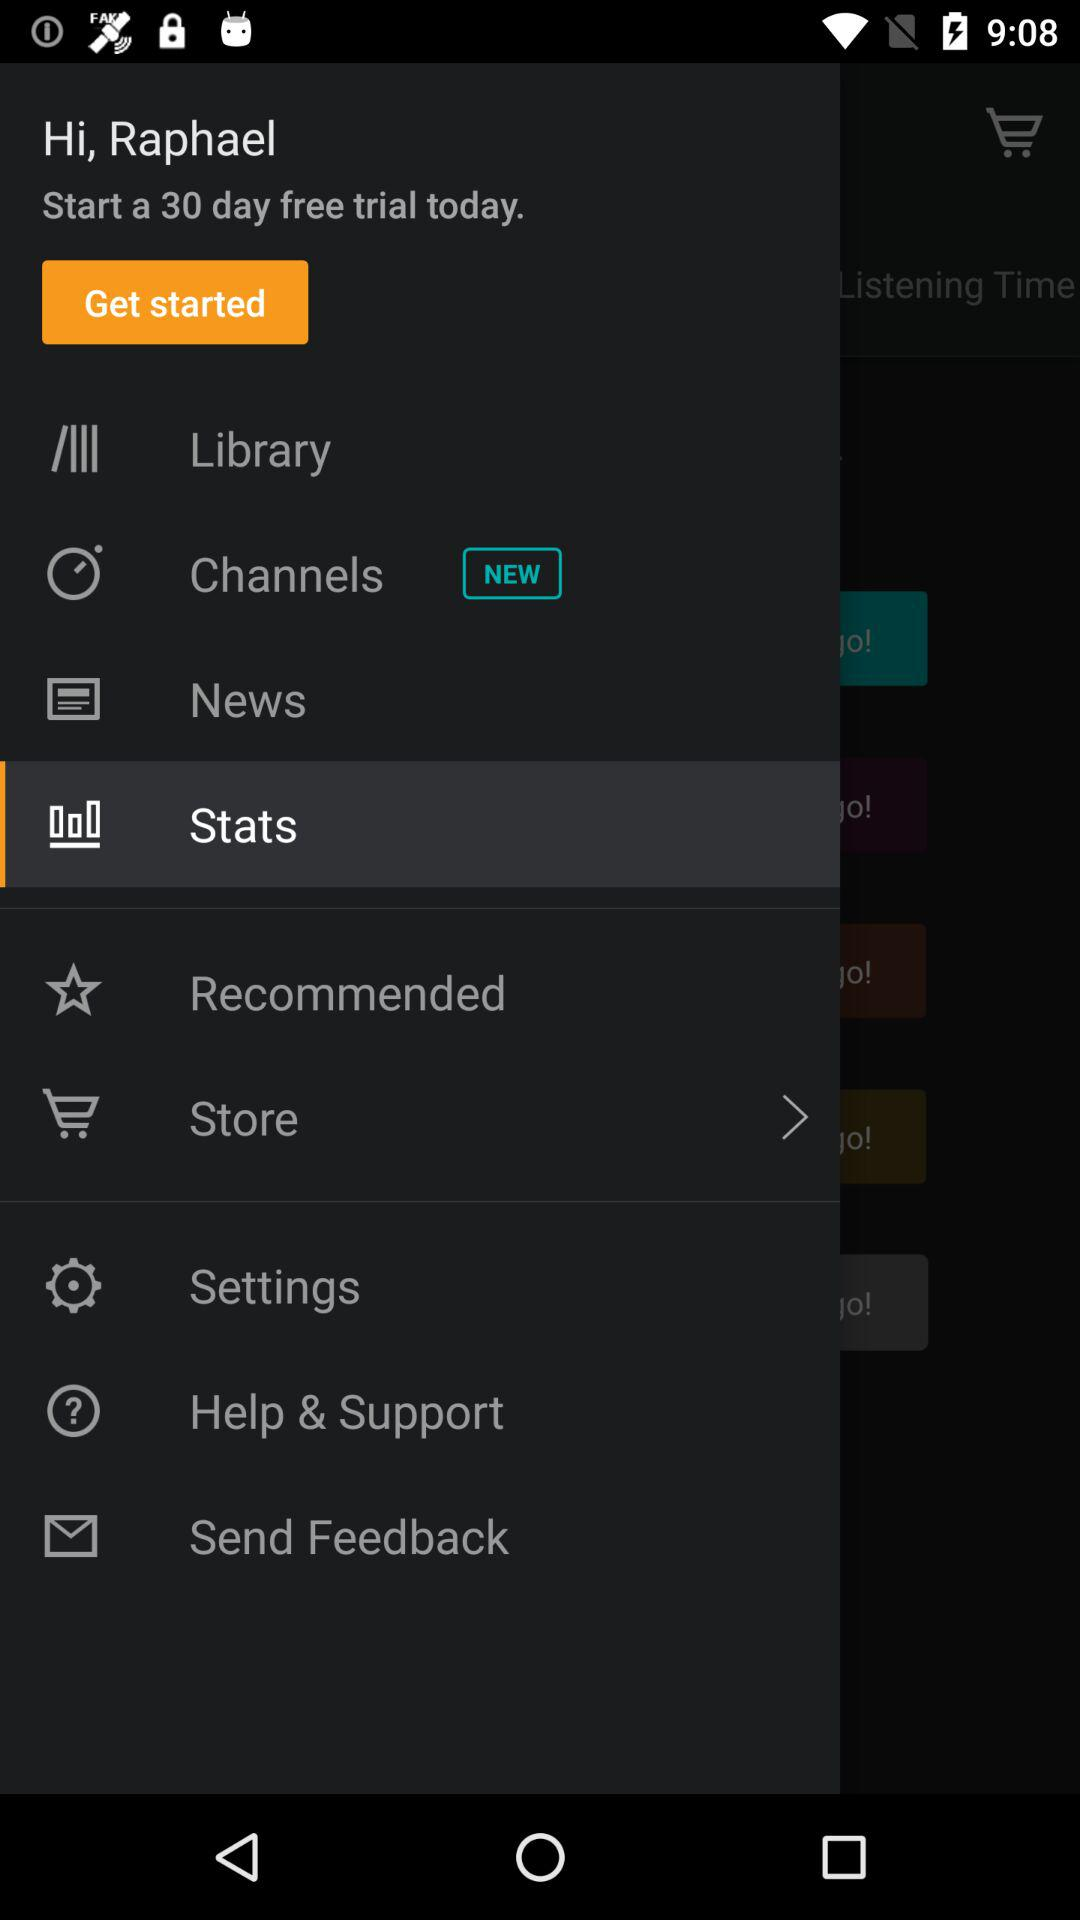Which item is available as new? The item that is available as new is "Channels". 